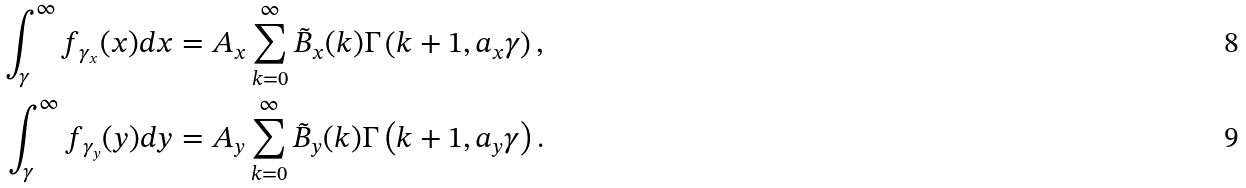<formula> <loc_0><loc_0><loc_500><loc_500>\int ^ { \infty } _ { \gamma } f _ { \gamma _ { x } } ( x ) d x & = A _ { x } \sum ^ { \infty } _ { k = 0 } \tilde { B } _ { x } ( k ) \Gamma \left ( k + 1 , a _ { x } \gamma \right ) , \\ \int ^ { \infty } _ { \gamma } f _ { \gamma _ { y } } ( y ) d y & = A _ { y } \sum ^ { \infty } _ { k = 0 } \tilde { B } _ { y } ( k ) \Gamma \left ( k + 1 , a _ { y } \gamma \right ) .</formula> 